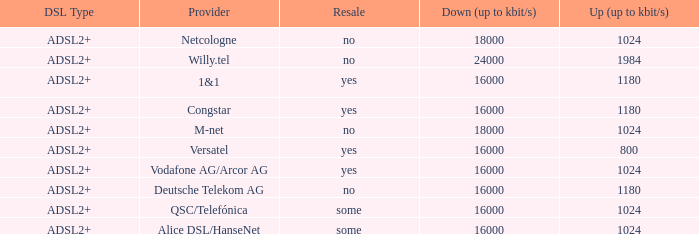What is download bandwith where the provider is deutsche telekom ag? 16000.0. 